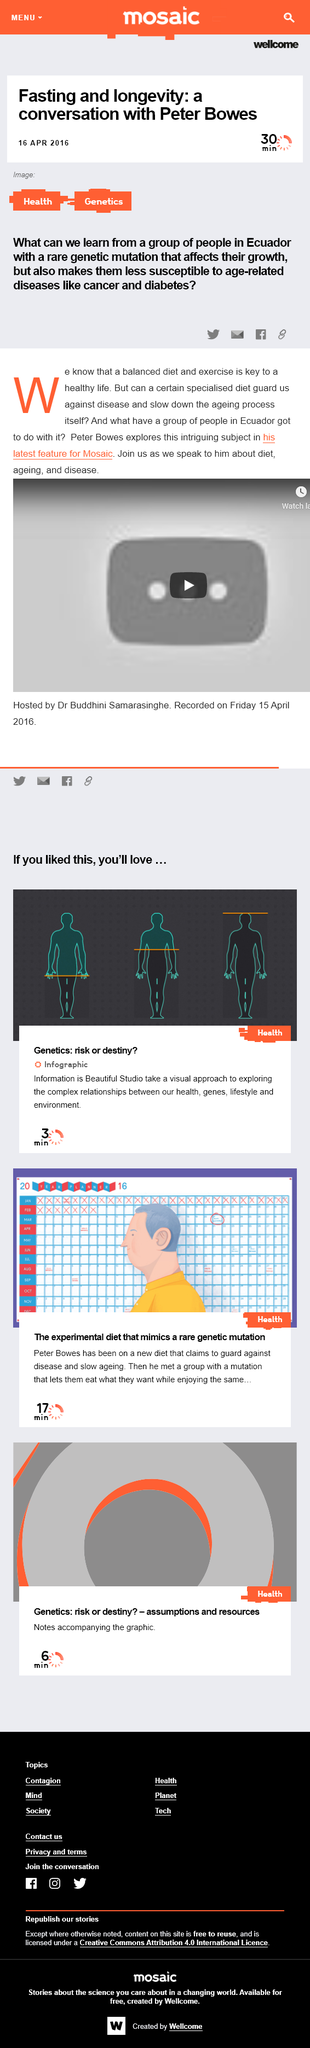Identify some key points in this picture. It is believed that people from Ecuador may possess age-defying genes. Peter Bowes published his feature in Mosaic. A balanced diet and regular exercise are the keys to a healthy lifestyle. 